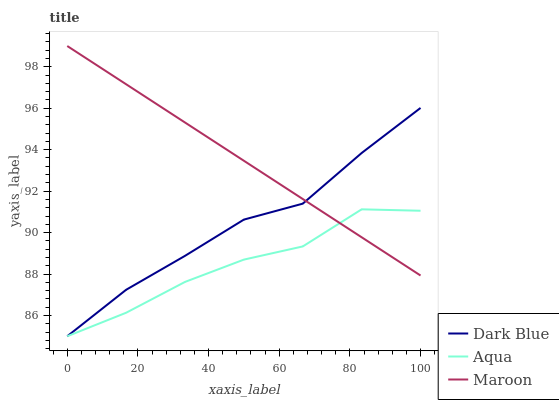Does Aqua have the minimum area under the curve?
Answer yes or no. Yes. Does Maroon have the maximum area under the curve?
Answer yes or no. Yes. Does Maroon have the minimum area under the curve?
Answer yes or no. No. Does Aqua have the maximum area under the curve?
Answer yes or no. No. Is Maroon the smoothest?
Answer yes or no. Yes. Is Aqua the roughest?
Answer yes or no. Yes. Is Aqua the smoothest?
Answer yes or no. No. Is Maroon the roughest?
Answer yes or no. No. Does Dark Blue have the lowest value?
Answer yes or no. Yes. Does Maroon have the lowest value?
Answer yes or no. No. Does Maroon have the highest value?
Answer yes or no. Yes. Does Aqua have the highest value?
Answer yes or no. No. Does Maroon intersect Dark Blue?
Answer yes or no. Yes. Is Maroon less than Dark Blue?
Answer yes or no. No. Is Maroon greater than Dark Blue?
Answer yes or no. No. 